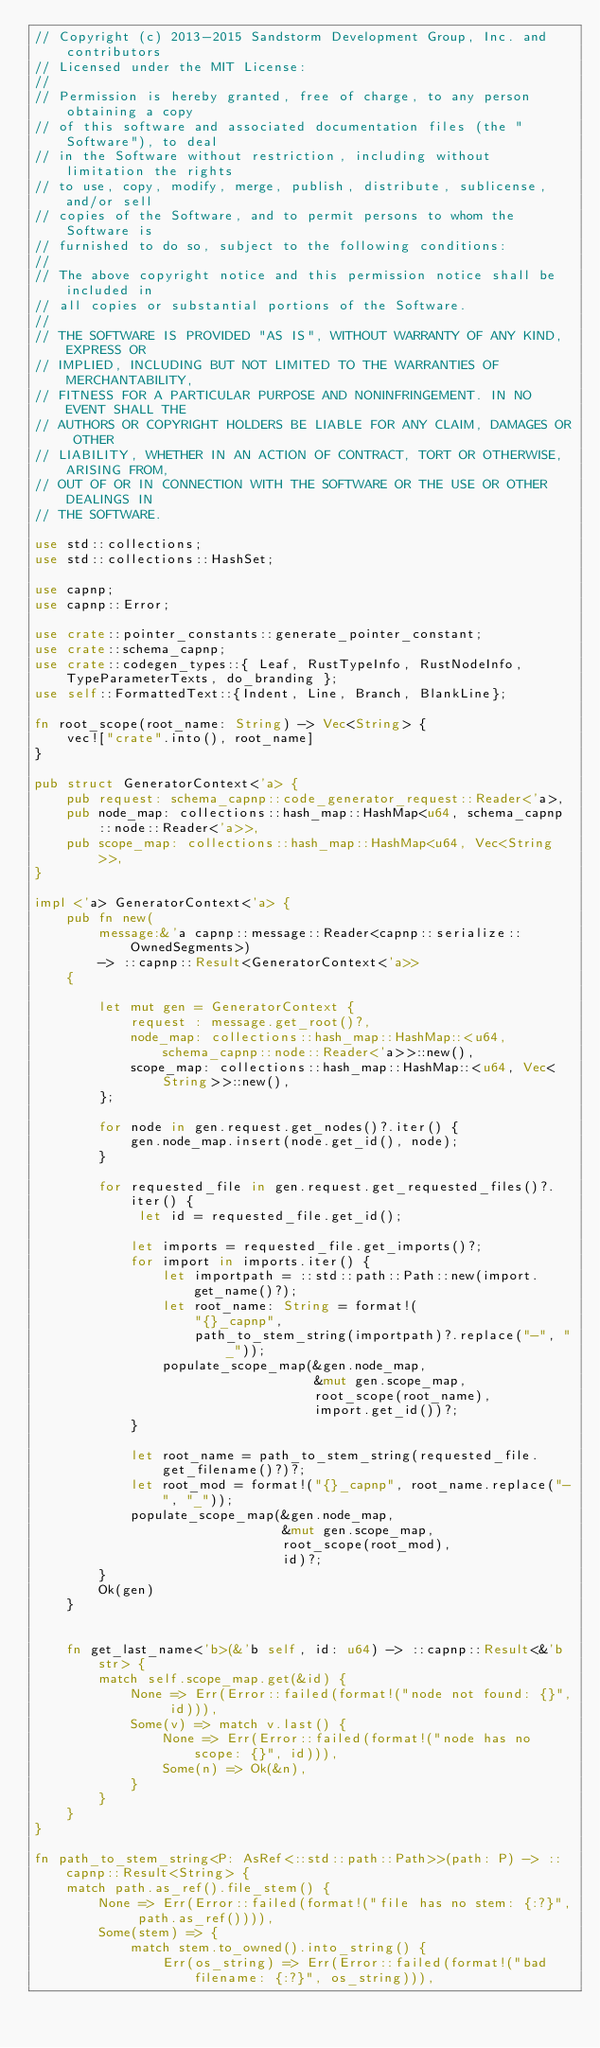Convert code to text. <code><loc_0><loc_0><loc_500><loc_500><_Rust_>// Copyright (c) 2013-2015 Sandstorm Development Group, Inc. and contributors
// Licensed under the MIT License:
//
// Permission is hereby granted, free of charge, to any person obtaining a copy
// of this software and associated documentation files (the "Software"), to deal
// in the Software without restriction, including without limitation the rights
// to use, copy, modify, merge, publish, distribute, sublicense, and/or sell
// copies of the Software, and to permit persons to whom the Software is
// furnished to do so, subject to the following conditions:
//
// The above copyright notice and this permission notice shall be included in
// all copies or substantial portions of the Software.
//
// THE SOFTWARE IS PROVIDED "AS IS", WITHOUT WARRANTY OF ANY KIND, EXPRESS OR
// IMPLIED, INCLUDING BUT NOT LIMITED TO THE WARRANTIES OF MERCHANTABILITY,
// FITNESS FOR A PARTICULAR PURPOSE AND NONINFRINGEMENT. IN NO EVENT SHALL THE
// AUTHORS OR COPYRIGHT HOLDERS BE LIABLE FOR ANY CLAIM, DAMAGES OR OTHER
// LIABILITY, WHETHER IN AN ACTION OF CONTRACT, TORT OR OTHERWISE, ARISING FROM,
// OUT OF OR IN CONNECTION WITH THE SOFTWARE OR THE USE OR OTHER DEALINGS IN
// THE SOFTWARE.

use std::collections;
use std::collections::HashSet;

use capnp;
use capnp::Error;

use crate::pointer_constants::generate_pointer_constant;
use crate::schema_capnp;
use crate::codegen_types::{ Leaf, RustTypeInfo, RustNodeInfo, TypeParameterTexts, do_branding };
use self::FormattedText::{Indent, Line, Branch, BlankLine};

fn root_scope(root_name: String) -> Vec<String> {
    vec!["crate".into(), root_name]
}

pub struct GeneratorContext<'a> {
    pub request: schema_capnp::code_generator_request::Reader<'a>,
    pub node_map: collections::hash_map::HashMap<u64, schema_capnp::node::Reader<'a>>,
    pub scope_map: collections::hash_map::HashMap<u64, Vec<String>>,
}

impl <'a> GeneratorContext<'a> {
    pub fn new(
        message:&'a capnp::message::Reader<capnp::serialize::OwnedSegments>)
        -> ::capnp::Result<GeneratorContext<'a>>
    {

        let mut gen = GeneratorContext {
            request : message.get_root()?,
            node_map: collections::hash_map::HashMap::<u64, schema_capnp::node::Reader<'a>>::new(),
            scope_map: collections::hash_map::HashMap::<u64, Vec<String>>::new(),
        };

        for node in gen.request.get_nodes()?.iter() {
            gen.node_map.insert(node.get_id(), node);
        }

        for requested_file in gen.request.get_requested_files()?.iter() {
             let id = requested_file.get_id();

            let imports = requested_file.get_imports()?;
            for import in imports.iter() {
                let importpath = ::std::path::Path::new(import.get_name()?);
                let root_name: String = format!(
                    "{}_capnp",
                    path_to_stem_string(importpath)?.replace("-", "_"));
                populate_scope_map(&gen.node_map,
                                   &mut gen.scope_map,
                                   root_scope(root_name),
                                   import.get_id())?;
            }

            let root_name = path_to_stem_string(requested_file.get_filename()?)?;
            let root_mod = format!("{}_capnp", root_name.replace("-", "_"));
            populate_scope_map(&gen.node_map,
                               &mut gen.scope_map,
                               root_scope(root_mod),
                               id)?;
        }
        Ok(gen)
    }


    fn get_last_name<'b>(&'b self, id: u64) -> ::capnp::Result<&'b str> {
        match self.scope_map.get(&id) {
            None => Err(Error::failed(format!("node not found: {}", id))),
            Some(v) => match v.last() {
                None => Err(Error::failed(format!("node has no scope: {}", id))),
                Some(n) => Ok(&n),
            }
        }
    }
}

fn path_to_stem_string<P: AsRef<::std::path::Path>>(path: P) -> ::capnp::Result<String> {
    match path.as_ref().file_stem() {
        None => Err(Error::failed(format!("file has no stem: {:?}", path.as_ref()))),
        Some(stem) => {
            match stem.to_owned().into_string() {
                Err(os_string) => Err(Error::failed(format!("bad filename: {:?}", os_string))),</code> 